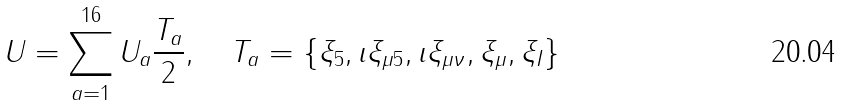<formula> <loc_0><loc_0><loc_500><loc_500>U = \sum ^ { 1 6 } _ { a = 1 } U _ { a } \frac { T _ { a } } { 2 } , \quad T _ { a } = \{ \xi _ { 5 } , \imath \xi _ { \mu 5 } , \imath \xi _ { \mu \nu } , \xi _ { \mu } , \xi _ { I } \}</formula> 